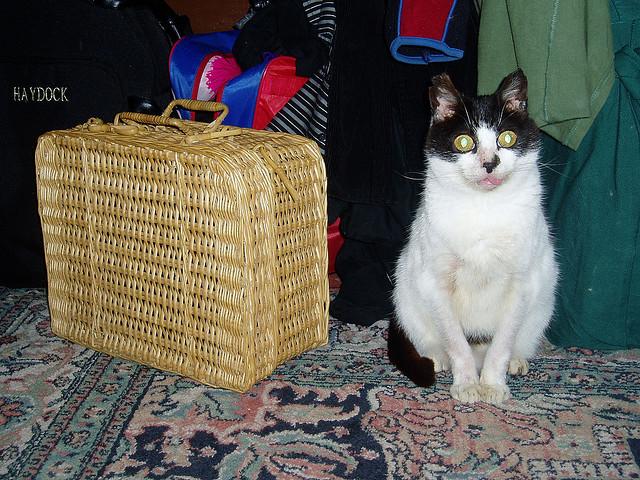What animal is this?
Concise answer only. Cat. Are those the cats real eyes?
Be succinct. Yes. What is the suitcase made of?
Write a very short answer. Wicker. 